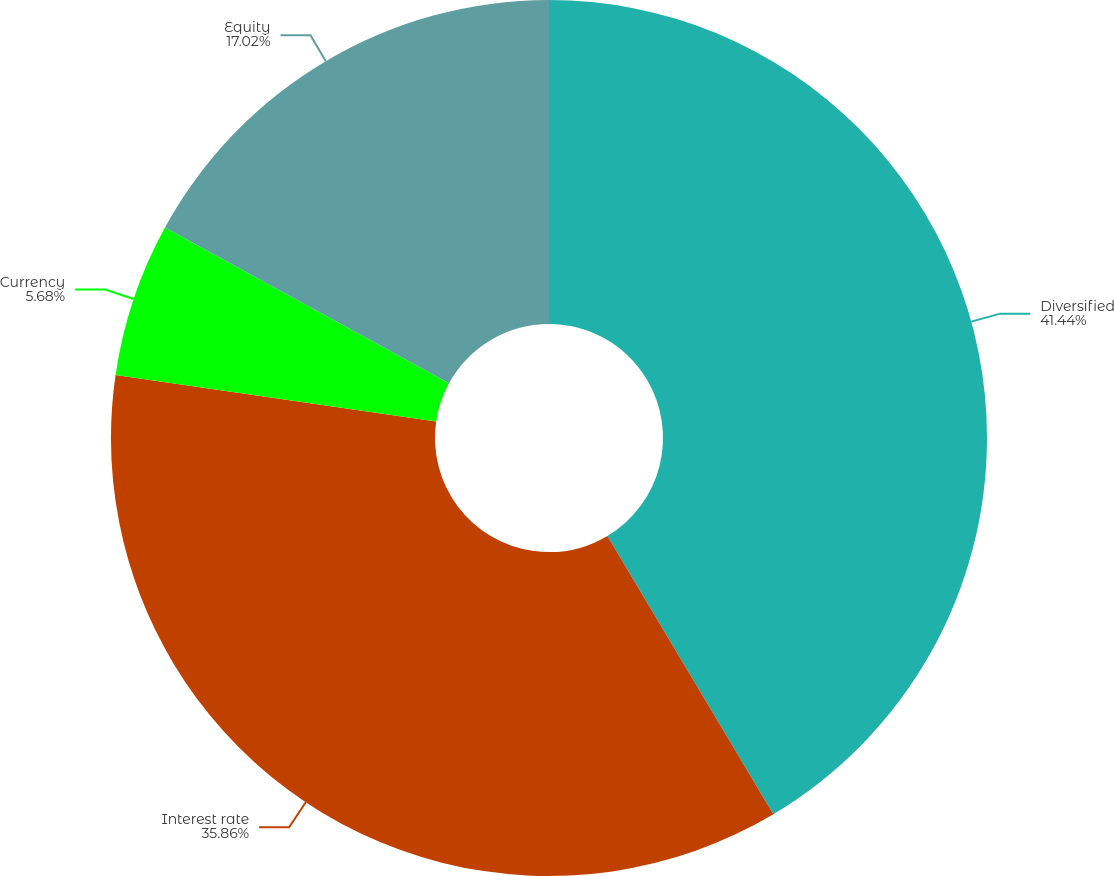Convert chart to OTSL. <chart><loc_0><loc_0><loc_500><loc_500><pie_chart><fcel>Diversified<fcel>Interest rate<fcel>Currency<fcel>Equity<nl><fcel>41.44%<fcel>35.86%<fcel>5.68%<fcel>17.02%<nl></chart> 